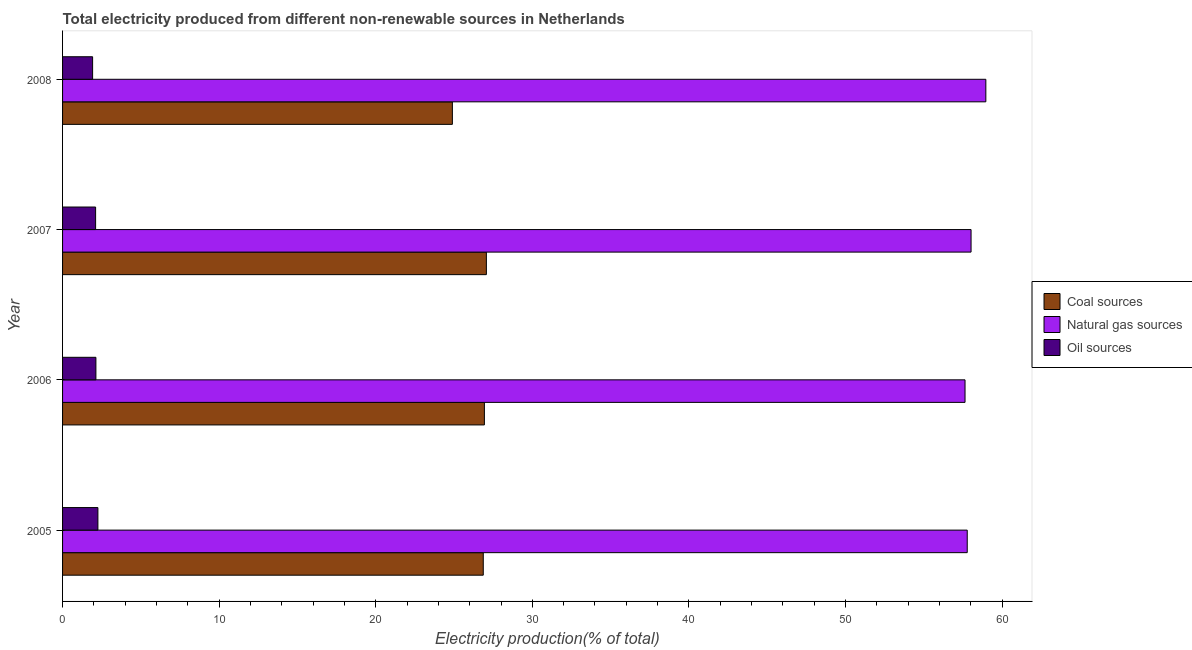How many bars are there on the 3rd tick from the top?
Your answer should be compact. 3. What is the label of the 3rd group of bars from the top?
Ensure brevity in your answer.  2006. What is the percentage of electricity produced by oil sources in 2005?
Ensure brevity in your answer.  2.26. Across all years, what is the maximum percentage of electricity produced by natural gas?
Make the answer very short. 58.96. Across all years, what is the minimum percentage of electricity produced by oil sources?
Make the answer very short. 1.92. What is the total percentage of electricity produced by natural gas in the graph?
Provide a succinct answer. 232.39. What is the difference between the percentage of electricity produced by oil sources in 2006 and that in 2008?
Give a very brief answer. 0.21. What is the difference between the percentage of electricity produced by natural gas in 2007 and the percentage of electricity produced by oil sources in 2005?
Offer a terse response. 55.76. What is the average percentage of electricity produced by coal per year?
Offer a very short reply. 26.44. In the year 2006, what is the difference between the percentage of electricity produced by oil sources and percentage of electricity produced by natural gas?
Ensure brevity in your answer.  -55.5. What is the ratio of the percentage of electricity produced by oil sources in 2005 to that in 2006?
Provide a short and direct response. 1.06. What is the difference between the highest and the second highest percentage of electricity produced by natural gas?
Offer a terse response. 0.94. What is the difference between the highest and the lowest percentage of electricity produced by natural gas?
Your answer should be very brief. 1.33. What does the 2nd bar from the top in 2007 represents?
Provide a short and direct response. Natural gas sources. What does the 3rd bar from the bottom in 2008 represents?
Offer a very short reply. Oil sources. How many years are there in the graph?
Provide a succinct answer. 4. How are the legend labels stacked?
Your answer should be compact. Vertical. What is the title of the graph?
Provide a succinct answer. Total electricity produced from different non-renewable sources in Netherlands. What is the Electricity production(% of total) of Coal sources in 2005?
Keep it short and to the point. 26.87. What is the Electricity production(% of total) of Natural gas sources in 2005?
Provide a short and direct response. 57.77. What is the Electricity production(% of total) of Oil sources in 2005?
Offer a terse response. 2.26. What is the Electricity production(% of total) in Coal sources in 2006?
Provide a succinct answer. 26.94. What is the Electricity production(% of total) in Natural gas sources in 2006?
Offer a very short reply. 57.63. What is the Electricity production(% of total) in Oil sources in 2006?
Your response must be concise. 2.13. What is the Electricity production(% of total) in Coal sources in 2007?
Your answer should be compact. 27.06. What is the Electricity production(% of total) of Natural gas sources in 2007?
Offer a very short reply. 58.02. What is the Electricity production(% of total) of Oil sources in 2007?
Ensure brevity in your answer.  2.11. What is the Electricity production(% of total) of Coal sources in 2008?
Keep it short and to the point. 24.89. What is the Electricity production(% of total) of Natural gas sources in 2008?
Your response must be concise. 58.96. What is the Electricity production(% of total) of Oil sources in 2008?
Your response must be concise. 1.92. Across all years, what is the maximum Electricity production(% of total) in Coal sources?
Provide a short and direct response. 27.06. Across all years, what is the maximum Electricity production(% of total) of Natural gas sources?
Offer a very short reply. 58.96. Across all years, what is the maximum Electricity production(% of total) of Oil sources?
Provide a succinct answer. 2.26. Across all years, what is the minimum Electricity production(% of total) of Coal sources?
Your answer should be very brief. 24.89. Across all years, what is the minimum Electricity production(% of total) of Natural gas sources?
Make the answer very short. 57.63. Across all years, what is the minimum Electricity production(% of total) of Oil sources?
Ensure brevity in your answer.  1.92. What is the total Electricity production(% of total) in Coal sources in the graph?
Offer a terse response. 105.76. What is the total Electricity production(% of total) in Natural gas sources in the graph?
Offer a very short reply. 232.39. What is the total Electricity production(% of total) of Oil sources in the graph?
Keep it short and to the point. 8.41. What is the difference between the Electricity production(% of total) of Coal sources in 2005 and that in 2006?
Your answer should be compact. -0.07. What is the difference between the Electricity production(% of total) in Natural gas sources in 2005 and that in 2006?
Ensure brevity in your answer.  0.14. What is the difference between the Electricity production(% of total) in Oil sources in 2005 and that in 2006?
Your response must be concise. 0.13. What is the difference between the Electricity production(% of total) of Coal sources in 2005 and that in 2007?
Your answer should be compact. -0.2. What is the difference between the Electricity production(% of total) in Natural gas sources in 2005 and that in 2007?
Provide a succinct answer. -0.24. What is the difference between the Electricity production(% of total) in Oil sources in 2005 and that in 2007?
Provide a short and direct response. 0.15. What is the difference between the Electricity production(% of total) in Coal sources in 2005 and that in 2008?
Your answer should be very brief. 1.97. What is the difference between the Electricity production(% of total) in Natural gas sources in 2005 and that in 2008?
Your response must be concise. -1.19. What is the difference between the Electricity production(% of total) of Oil sources in 2005 and that in 2008?
Offer a very short reply. 0.34. What is the difference between the Electricity production(% of total) of Coal sources in 2006 and that in 2007?
Ensure brevity in your answer.  -0.13. What is the difference between the Electricity production(% of total) of Natural gas sources in 2006 and that in 2007?
Ensure brevity in your answer.  -0.38. What is the difference between the Electricity production(% of total) in Oil sources in 2006 and that in 2007?
Offer a very short reply. 0.02. What is the difference between the Electricity production(% of total) in Coal sources in 2006 and that in 2008?
Provide a succinct answer. 2.04. What is the difference between the Electricity production(% of total) of Natural gas sources in 2006 and that in 2008?
Keep it short and to the point. -1.33. What is the difference between the Electricity production(% of total) in Oil sources in 2006 and that in 2008?
Offer a very short reply. 0.21. What is the difference between the Electricity production(% of total) in Coal sources in 2007 and that in 2008?
Offer a very short reply. 2.17. What is the difference between the Electricity production(% of total) of Natural gas sources in 2007 and that in 2008?
Offer a terse response. -0.94. What is the difference between the Electricity production(% of total) of Oil sources in 2007 and that in 2008?
Ensure brevity in your answer.  0.19. What is the difference between the Electricity production(% of total) of Coal sources in 2005 and the Electricity production(% of total) of Natural gas sources in 2006?
Your response must be concise. -30.77. What is the difference between the Electricity production(% of total) of Coal sources in 2005 and the Electricity production(% of total) of Oil sources in 2006?
Offer a terse response. 24.74. What is the difference between the Electricity production(% of total) of Natural gas sources in 2005 and the Electricity production(% of total) of Oil sources in 2006?
Provide a short and direct response. 55.64. What is the difference between the Electricity production(% of total) in Coal sources in 2005 and the Electricity production(% of total) in Natural gas sources in 2007?
Your response must be concise. -31.15. What is the difference between the Electricity production(% of total) in Coal sources in 2005 and the Electricity production(% of total) in Oil sources in 2007?
Give a very brief answer. 24.76. What is the difference between the Electricity production(% of total) in Natural gas sources in 2005 and the Electricity production(% of total) in Oil sources in 2007?
Your response must be concise. 55.66. What is the difference between the Electricity production(% of total) in Coal sources in 2005 and the Electricity production(% of total) in Natural gas sources in 2008?
Provide a short and direct response. -32.1. What is the difference between the Electricity production(% of total) in Coal sources in 2005 and the Electricity production(% of total) in Oil sources in 2008?
Make the answer very short. 24.95. What is the difference between the Electricity production(% of total) of Natural gas sources in 2005 and the Electricity production(% of total) of Oil sources in 2008?
Your response must be concise. 55.86. What is the difference between the Electricity production(% of total) in Coal sources in 2006 and the Electricity production(% of total) in Natural gas sources in 2007?
Keep it short and to the point. -31.08. What is the difference between the Electricity production(% of total) in Coal sources in 2006 and the Electricity production(% of total) in Oil sources in 2007?
Your response must be concise. 24.83. What is the difference between the Electricity production(% of total) of Natural gas sources in 2006 and the Electricity production(% of total) of Oil sources in 2007?
Your answer should be compact. 55.52. What is the difference between the Electricity production(% of total) in Coal sources in 2006 and the Electricity production(% of total) in Natural gas sources in 2008?
Your answer should be compact. -32.02. What is the difference between the Electricity production(% of total) in Coal sources in 2006 and the Electricity production(% of total) in Oil sources in 2008?
Offer a very short reply. 25.02. What is the difference between the Electricity production(% of total) of Natural gas sources in 2006 and the Electricity production(% of total) of Oil sources in 2008?
Your answer should be very brief. 55.71. What is the difference between the Electricity production(% of total) in Coal sources in 2007 and the Electricity production(% of total) in Natural gas sources in 2008?
Your answer should be compact. -31.9. What is the difference between the Electricity production(% of total) in Coal sources in 2007 and the Electricity production(% of total) in Oil sources in 2008?
Provide a succinct answer. 25.15. What is the difference between the Electricity production(% of total) of Natural gas sources in 2007 and the Electricity production(% of total) of Oil sources in 2008?
Your answer should be compact. 56.1. What is the average Electricity production(% of total) of Coal sources per year?
Provide a short and direct response. 26.44. What is the average Electricity production(% of total) in Natural gas sources per year?
Keep it short and to the point. 58.1. What is the average Electricity production(% of total) in Oil sources per year?
Your answer should be compact. 2.1. In the year 2005, what is the difference between the Electricity production(% of total) of Coal sources and Electricity production(% of total) of Natural gas sources?
Give a very brief answer. -30.91. In the year 2005, what is the difference between the Electricity production(% of total) in Coal sources and Electricity production(% of total) in Oil sources?
Your response must be concise. 24.61. In the year 2005, what is the difference between the Electricity production(% of total) in Natural gas sources and Electricity production(% of total) in Oil sources?
Make the answer very short. 55.52. In the year 2006, what is the difference between the Electricity production(% of total) in Coal sources and Electricity production(% of total) in Natural gas sources?
Your response must be concise. -30.69. In the year 2006, what is the difference between the Electricity production(% of total) in Coal sources and Electricity production(% of total) in Oil sources?
Ensure brevity in your answer.  24.81. In the year 2006, what is the difference between the Electricity production(% of total) of Natural gas sources and Electricity production(% of total) of Oil sources?
Provide a succinct answer. 55.5. In the year 2007, what is the difference between the Electricity production(% of total) in Coal sources and Electricity production(% of total) in Natural gas sources?
Ensure brevity in your answer.  -30.95. In the year 2007, what is the difference between the Electricity production(% of total) in Coal sources and Electricity production(% of total) in Oil sources?
Your answer should be compact. 24.95. In the year 2007, what is the difference between the Electricity production(% of total) of Natural gas sources and Electricity production(% of total) of Oil sources?
Offer a terse response. 55.91. In the year 2008, what is the difference between the Electricity production(% of total) of Coal sources and Electricity production(% of total) of Natural gas sources?
Make the answer very short. -34.07. In the year 2008, what is the difference between the Electricity production(% of total) in Coal sources and Electricity production(% of total) in Oil sources?
Keep it short and to the point. 22.98. In the year 2008, what is the difference between the Electricity production(% of total) in Natural gas sources and Electricity production(% of total) in Oil sources?
Make the answer very short. 57.04. What is the ratio of the Electricity production(% of total) of Oil sources in 2005 to that in 2006?
Ensure brevity in your answer.  1.06. What is the ratio of the Electricity production(% of total) of Coal sources in 2005 to that in 2007?
Give a very brief answer. 0.99. What is the ratio of the Electricity production(% of total) in Oil sources in 2005 to that in 2007?
Your answer should be compact. 1.07. What is the ratio of the Electricity production(% of total) of Coal sources in 2005 to that in 2008?
Offer a very short reply. 1.08. What is the ratio of the Electricity production(% of total) of Natural gas sources in 2005 to that in 2008?
Provide a short and direct response. 0.98. What is the ratio of the Electricity production(% of total) in Oil sources in 2005 to that in 2008?
Your answer should be compact. 1.18. What is the ratio of the Electricity production(% of total) in Coal sources in 2006 to that in 2007?
Keep it short and to the point. 1. What is the ratio of the Electricity production(% of total) in Natural gas sources in 2006 to that in 2007?
Offer a very short reply. 0.99. What is the ratio of the Electricity production(% of total) of Oil sources in 2006 to that in 2007?
Provide a short and direct response. 1.01. What is the ratio of the Electricity production(% of total) in Coal sources in 2006 to that in 2008?
Offer a terse response. 1.08. What is the ratio of the Electricity production(% of total) of Natural gas sources in 2006 to that in 2008?
Provide a succinct answer. 0.98. What is the ratio of the Electricity production(% of total) of Oil sources in 2006 to that in 2008?
Offer a very short reply. 1.11. What is the ratio of the Electricity production(% of total) in Coal sources in 2007 to that in 2008?
Make the answer very short. 1.09. What is the ratio of the Electricity production(% of total) in Oil sources in 2007 to that in 2008?
Keep it short and to the point. 1.1. What is the difference between the highest and the second highest Electricity production(% of total) of Coal sources?
Offer a very short reply. 0.13. What is the difference between the highest and the second highest Electricity production(% of total) of Natural gas sources?
Your answer should be very brief. 0.94. What is the difference between the highest and the second highest Electricity production(% of total) in Oil sources?
Offer a very short reply. 0.13. What is the difference between the highest and the lowest Electricity production(% of total) of Coal sources?
Make the answer very short. 2.17. What is the difference between the highest and the lowest Electricity production(% of total) of Natural gas sources?
Give a very brief answer. 1.33. What is the difference between the highest and the lowest Electricity production(% of total) of Oil sources?
Provide a succinct answer. 0.34. 